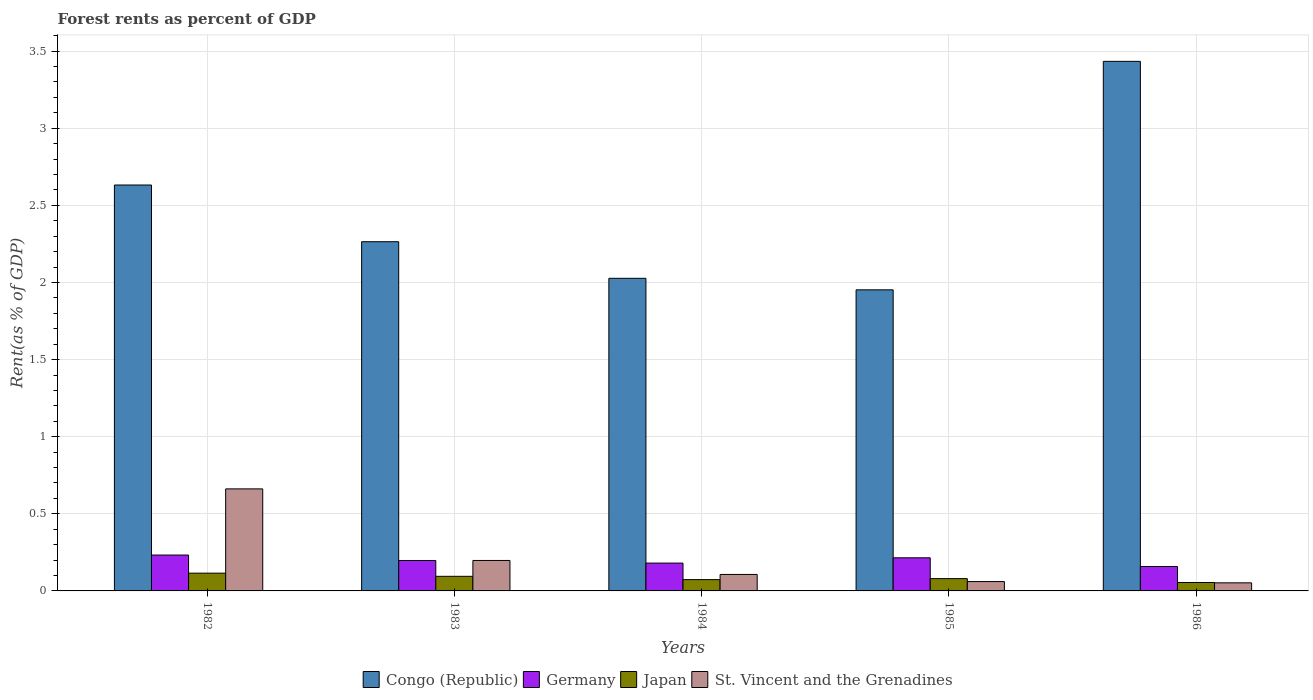How many groups of bars are there?
Provide a short and direct response. 5. Are the number of bars on each tick of the X-axis equal?
Give a very brief answer. Yes. What is the label of the 4th group of bars from the left?
Keep it short and to the point. 1985. What is the forest rent in Germany in 1983?
Give a very brief answer. 0.2. Across all years, what is the maximum forest rent in Japan?
Keep it short and to the point. 0.12. Across all years, what is the minimum forest rent in Japan?
Offer a very short reply. 0.05. In which year was the forest rent in St. Vincent and the Grenadines maximum?
Your response must be concise. 1982. What is the total forest rent in Japan in the graph?
Offer a terse response. 0.42. What is the difference between the forest rent in St. Vincent and the Grenadines in 1983 and that in 1986?
Make the answer very short. 0.15. What is the difference between the forest rent in Japan in 1982 and the forest rent in Germany in 1984?
Your response must be concise. -0.07. What is the average forest rent in Congo (Republic) per year?
Provide a succinct answer. 2.46. In the year 1982, what is the difference between the forest rent in Congo (Republic) and forest rent in Germany?
Ensure brevity in your answer.  2.4. What is the ratio of the forest rent in Japan in 1985 to that in 1986?
Provide a succinct answer. 1.46. Is the forest rent in Congo (Republic) in 1983 less than that in 1985?
Make the answer very short. No. Is the difference between the forest rent in Congo (Republic) in 1984 and 1986 greater than the difference between the forest rent in Germany in 1984 and 1986?
Make the answer very short. No. What is the difference between the highest and the second highest forest rent in St. Vincent and the Grenadines?
Your answer should be very brief. 0.46. What is the difference between the highest and the lowest forest rent in Japan?
Make the answer very short. 0.06. In how many years, is the forest rent in Germany greater than the average forest rent in Germany taken over all years?
Provide a succinct answer. 3. Is the sum of the forest rent in St. Vincent and the Grenadines in 1984 and 1985 greater than the maximum forest rent in Japan across all years?
Make the answer very short. Yes. Is it the case that in every year, the sum of the forest rent in Japan and forest rent in Congo (Republic) is greater than the sum of forest rent in Germany and forest rent in St. Vincent and the Grenadines?
Ensure brevity in your answer.  Yes. What does the 3rd bar from the right in 1985 represents?
Keep it short and to the point. Germany. Is it the case that in every year, the sum of the forest rent in Congo (Republic) and forest rent in St. Vincent and the Grenadines is greater than the forest rent in Germany?
Your response must be concise. Yes. How many bars are there?
Offer a terse response. 20. Are all the bars in the graph horizontal?
Offer a terse response. No. What is the difference between two consecutive major ticks on the Y-axis?
Provide a short and direct response. 0.5. Are the values on the major ticks of Y-axis written in scientific E-notation?
Provide a succinct answer. No. Does the graph contain any zero values?
Your answer should be compact. No. Where does the legend appear in the graph?
Ensure brevity in your answer.  Bottom center. How many legend labels are there?
Offer a very short reply. 4. How are the legend labels stacked?
Your answer should be compact. Horizontal. What is the title of the graph?
Your response must be concise. Forest rents as percent of GDP. Does "Tajikistan" appear as one of the legend labels in the graph?
Provide a succinct answer. No. What is the label or title of the X-axis?
Your answer should be very brief. Years. What is the label or title of the Y-axis?
Make the answer very short. Rent(as % of GDP). What is the Rent(as % of GDP) in Congo (Republic) in 1982?
Keep it short and to the point. 2.63. What is the Rent(as % of GDP) in Germany in 1982?
Ensure brevity in your answer.  0.23. What is the Rent(as % of GDP) of Japan in 1982?
Offer a terse response. 0.12. What is the Rent(as % of GDP) in St. Vincent and the Grenadines in 1982?
Ensure brevity in your answer.  0.66. What is the Rent(as % of GDP) of Congo (Republic) in 1983?
Give a very brief answer. 2.26. What is the Rent(as % of GDP) in Germany in 1983?
Provide a short and direct response. 0.2. What is the Rent(as % of GDP) in Japan in 1983?
Give a very brief answer. 0.09. What is the Rent(as % of GDP) of St. Vincent and the Grenadines in 1983?
Offer a terse response. 0.2. What is the Rent(as % of GDP) of Congo (Republic) in 1984?
Your answer should be compact. 2.03. What is the Rent(as % of GDP) of Germany in 1984?
Offer a terse response. 0.18. What is the Rent(as % of GDP) in Japan in 1984?
Give a very brief answer. 0.07. What is the Rent(as % of GDP) in St. Vincent and the Grenadines in 1984?
Make the answer very short. 0.11. What is the Rent(as % of GDP) in Congo (Republic) in 1985?
Your answer should be very brief. 1.95. What is the Rent(as % of GDP) of Germany in 1985?
Ensure brevity in your answer.  0.21. What is the Rent(as % of GDP) in Japan in 1985?
Give a very brief answer. 0.08. What is the Rent(as % of GDP) in St. Vincent and the Grenadines in 1985?
Give a very brief answer. 0.06. What is the Rent(as % of GDP) in Congo (Republic) in 1986?
Your answer should be compact. 3.43. What is the Rent(as % of GDP) in Germany in 1986?
Provide a short and direct response. 0.16. What is the Rent(as % of GDP) of Japan in 1986?
Provide a succinct answer. 0.05. What is the Rent(as % of GDP) in St. Vincent and the Grenadines in 1986?
Keep it short and to the point. 0.05. Across all years, what is the maximum Rent(as % of GDP) in Congo (Republic)?
Give a very brief answer. 3.43. Across all years, what is the maximum Rent(as % of GDP) of Germany?
Offer a terse response. 0.23. Across all years, what is the maximum Rent(as % of GDP) in Japan?
Offer a terse response. 0.12. Across all years, what is the maximum Rent(as % of GDP) of St. Vincent and the Grenadines?
Offer a very short reply. 0.66. Across all years, what is the minimum Rent(as % of GDP) in Congo (Republic)?
Your response must be concise. 1.95. Across all years, what is the minimum Rent(as % of GDP) in Germany?
Offer a terse response. 0.16. Across all years, what is the minimum Rent(as % of GDP) of Japan?
Offer a very short reply. 0.05. Across all years, what is the minimum Rent(as % of GDP) in St. Vincent and the Grenadines?
Keep it short and to the point. 0.05. What is the total Rent(as % of GDP) of Congo (Republic) in the graph?
Provide a short and direct response. 12.31. What is the total Rent(as % of GDP) of Germany in the graph?
Your answer should be compact. 0.98. What is the total Rent(as % of GDP) of Japan in the graph?
Ensure brevity in your answer.  0.42. What is the total Rent(as % of GDP) in St. Vincent and the Grenadines in the graph?
Your answer should be compact. 1.08. What is the difference between the Rent(as % of GDP) of Congo (Republic) in 1982 and that in 1983?
Make the answer very short. 0.37. What is the difference between the Rent(as % of GDP) in Germany in 1982 and that in 1983?
Provide a succinct answer. 0.04. What is the difference between the Rent(as % of GDP) in Japan in 1982 and that in 1983?
Your answer should be very brief. 0.02. What is the difference between the Rent(as % of GDP) in St. Vincent and the Grenadines in 1982 and that in 1983?
Offer a very short reply. 0.46. What is the difference between the Rent(as % of GDP) in Congo (Republic) in 1982 and that in 1984?
Your response must be concise. 0.6. What is the difference between the Rent(as % of GDP) in Germany in 1982 and that in 1984?
Provide a succinct answer. 0.05. What is the difference between the Rent(as % of GDP) of Japan in 1982 and that in 1984?
Offer a terse response. 0.04. What is the difference between the Rent(as % of GDP) in St. Vincent and the Grenadines in 1982 and that in 1984?
Your response must be concise. 0.55. What is the difference between the Rent(as % of GDP) of Congo (Republic) in 1982 and that in 1985?
Give a very brief answer. 0.68. What is the difference between the Rent(as % of GDP) in Germany in 1982 and that in 1985?
Give a very brief answer. 0.02. What is the difference between the Rent(as % of GDP) of Japan in 1982 and that in 1985?
Provide a succinct answer. 0.04. What is the difference between the Rent(as % of GDP) in St. Vincent and the Grenadines in 1982 and that in 1985?
Give a very brief answer. 0.6. What is the difference between the Rent(as % of GDP) of Congo (Republic) in 1982 and that in 1986?
Give a very brief answer. -0.8. What is the difference between the Rent(as % of GDP) of Germany in 1982 and that in 1986?
Offer a terse response. 0.07. What is the difference between the Rent(as % of GDP) of Japan in 1982 and that in 1986?
Your answer should be compact. 0.06. What is the difference between the Rent(as % of GDP) in St. Vincent and the Grenadines in 1982 and that in 1986?
Give a very brief answer. 0.61. What is the difference between the Rent(as % of GDP) in Congo (Republic) in 1983 and that in 1984?
Offer a terse response. 0.24. What is the difference between the Rent(as % of GDP) of Germany in 1983 and that in 1984?
Make the answer very short. 0.02. What is the difference between the Rent(as % of GDP) of Japan in 1983 and that in 1984?
Ensure brevity in your answer.  0.02. What is the difference between the Rent(as % of GDP) of St. Vincent and the Grenadines in 1983 and that in 1984?
Your answer should be compact. 0.09. What is the difference between the Rent(as % of GDP) in Congo (Republic) in 1983 and that in 1985?
Give a very brief answer. 0.31. What is the difference between the Rent(as % of GDP) of Germany in 1983 and that in 1985?
Make the answer very short. -0.02. What is the difference between the Rent(as % of GDP) in Japan in 1983 and that in 1985?
Make the answer very short. 0.01. What is the difference between the Rent(as % of GDP) in St. Vincent and the Grenadines in 1983 and that in 1985?
Ensure brevity in your answer.  0.14. What is the difference between the Rent(as % of GDP) of Congo (Republic) in 1983 and that in 1986?
Offer a very short reply. -1.17. What is the difference between the Rent(as % of GDP) in Germany in 1983 and that in 1986?
Provide a succinct answer. 0.04. What is the difference between the Rent(as % of GDP) of Japan in 1983 and that in 1986?
Offer a terse response. 0.04. What is the difference between the Rent(as % of GDP) of St. Vincent and the Grenadines in 1983 and that in 1986?
Your answer should be compact. 0.14. What is the difference between the Rent(as % of GDP) of Congo (Republic) in 1984 and that in 1985?
Offer a terse response. 0.07. What is the difference between the Rent(as % of GDP) in Germany in 1984 and that in 1985?
Ensure brevity in your answer.  -0.03. What is the difference between the Rent(as % of GDP) of Japan in 1984 and that in 1985?
Give a very brief answer. -0.01. What is the difference between the Rent(as % of GDP) of St. Vincent and the Grenadines in 1984 and that in 1985?
Keep it short and to the point. 0.05. What is the difference between the Rent(as % of GDP) in Congo (Republic) in 1984 and that in 1986?
Your answer should be very brief. -1.41. What is the difference between the Rent(as % of GDP) of Germany in 1984 and that in 1986?
Offer a terse response. 0.02. What is the difference between the Rent(as % of GDP) of Japan in 1984 and that in 1986?
Give a very brief answer. 0.02. What is the difference between the Rent(as % of GDP) in St. Vincent and the Grenadines in 1984 and that in 1986?
Your response must be concise. 0.05. What is the difference between the Rent(as % of GDP) of Congo (Republic) in 1985 and that in 1986?
Provide a succinct answer. -1.48. What is the difference between the Rent(as % of GDP) in Germany in 1985 and that in 1986?
Provide a short and direct response. 0.06. What is the difference between the Rent(as % of GDP) of Japan in 1985 and that in 1986?
Your answer should be very brief. 0.03. What is the difference between the Rent(as % of GDP) in St. Vincent and the Grenadines in 1985 and that in 1986?
Make the answer very short. 0.01. What is the difference between the Rent(as % of GDP) of Congo (Republic) in 1982 and the Rent(as % of GDP) of Germany in 1983?
Your answer should be compact. 2.43. What is the difference between the Rent(as % of GDP) of Congo (Republic) in 1982 and the Rent(as % of GDP) of Japan in 1983?
Offer a terse response. 2.54. What is the difference between the Rent(as % of GDP) in Congo (Republic) in 1982 and the Rent(as % of GDP) in St. Vincent and the Grenadines in 1983?
Your answer should be compact. 2.43. What is the difference between the Rent(as % of GDP) in Germany in 1982 and the Rent(as % of GDP) in Japan in 1983?
Your response must be concise. 0.14. What is the difference between the Rent(as % of GDP) of Germany in 1982 and the Rent(as % of GDP) of St. Vincent and the Grenadines in 1983?
Your response must be concise. 0.04. What is the difference between the Rent(as % of GDP) in Japan in 1982 and the Rent(as % of GDP) in St. Vincent and the Grenadines in 1983?
Provide a short and direct response. -0.08. What is the difference between the Rent(as % of GDP) in Congo (Republic) in 1982 and the Rent(as % of GDP) in Germany in 1984?
Your response must be concise. 2.45. What is the difference between the Rent(as % of GDP) in Congo (Republic) in 1982 and the Rent(as % of GDP) in Japan in 1984?
Provide a short and direct response. 2.56. What is the difference between the Rent(as % of GDP) in Congo (Republic) in 1982 and the Rent(as % of GDP) in St. Vincent and the Grenadines in 1984?
Your answer should be compact. 2.52. What is the difference between the Rent(as % of GDP) in Germany in 1982 and the Rent(as % of GDP) in Japan in 1984?
Offer a terse response. 0.16. What is the difference between the Rent(as % of GDP) of Germany in 1982 and the Rent(as % of GDP) of St. Vincent and the Grenadines in 1984?
Provide a succinct answer. 0.13. What is the difference between the Rent(as % of GDP) in Japan in 1982 and the Rent(as % of GDP) in St. Vincent and the Grenadines in 1984?
Give a very brief answer. 0.01. What is the difference between the Rent(as % of GDP) in Congo (Republic) in 1982 and the Rent(as % of GDP) in Germany in 1985?
Provide a short and direct response. 2.42. What is the difference between the Rent(as % of GDP) of Congo (Republic) in 1982 and the Rent(as % of GDP) of Japan in 1985?
Ensure brevity in your answer.  2.55. What is the difference between the Rent(as % of GDP) of Congo (Republic) in 1982 and the Rent(as % of GDP) of St. Vincent and the Grenadines in 1985?
Keep it short and to the point. 2.57. What is the difference between the Rent(as % of GDP) in Germany in 1982 and the Rent(as % of GDP) in Japan in 1985?
Your response must be concise. 0.15. What is the difference between the Rent(as % of GDP) in Germany in 1982 and the Rent(as % of GDP) in St. Vincent and the Grenadines in 1985?
Offer a very short reply. 0.17. What is the difference between the Rent(as % of GDP) of Japan in 1982 and the Rent(as % of GDP) of St. Vincent and the Grenadines in 1985?
Give a very brief answer. 0.05. What is the difference between the Rent(as % of GDP) in Congo (Republic) in 1982 and the Rent(as % of GDP) in Germany in 1986?
Give a very brief answer. 2.47. What is the difference between the Rent(as % of GDP) in Congo (Republic) in 1982 and the Rent(as % of GDP) in Japan in 1986?
Ensure brevity in your answer.  2.58. What is the difference between the Rent(as % of GDP) of Congo (Republic) in 1982 and the Rent(as % of GDP) of St. Vincent and the Grenadines in 1986?
Your answer should be compact. 2.58. What is the difference between the Rent(as % of GDP) in Germany in 1982 and the Rent(as % of GDP) in Japan in 1986?
Provide a succinct answer. 0.18. What is the difference between the Rent(as % of GDP) of Germany in 1982 and the Rent(as % of GDP) of St. Vincent and the Grenadines in 1986?
Give a very brief answer. 0.18. What is the difference between the Rent(as % of GDP) of Japan in 1982 and the Rent(as % of GDP) of St. Vincent and the Grenadines in 1986?
Provide a succinct answer. 0.06. What is the difference between the Rent(as % of GDP) in Congo (Republic) in 1983 and the Rent(as % of GDP) in Germany in 1984?
Ensure brevity in your answer.  2.08. What is the difference between the Rent(as % of GDP) of Congo (Republic) in 1983 and the Rent(as % of GDP) of Japan in 1984?
Your response must be concise. 2.19. What is the difference between the Rent(as % of GDP) of Congo (Republic) in 1983 and the Rent(as % of GDP) of St. Vincent and the Grenadines in 1984?
Your response must be concise. 2.16. What is the difference between the Rent(as % of GDP) in Germany in 1983 and the Rent(as % of GDP) in Japan in 1984?
Offer a very short reply. 0.12. What is the difference between the Rent(as % of GDP) of Germany in 1983 and the Rent(as % of GDP) of St. Vincent and the Grenadines in 1984?
Keep it short and to the point. 0.09. What is the difference between the Rent(as % of GDP) of Japan in 1983 and the Rent(as % of GDP) of St. Vincent and the Grenadines in 1984?
Offer a very short reply. -0.01. What is the difference between the Rent(as % of GDP) of Congo (Republic) in 1983 and the Rent(as % of GDP) of Germany in 1985?
Ensure brevity in your answer.  2.05. What is the difference between the Rent(as % of GDP) in Congo (Republic) in 1983 and the Rent(as % of GDP) in Japan in 1985?
Your answer should be compact. 2.18. What is the difference between the Rent(as % of GDP) in Congo (Republic) in 1983 and the Rent(as % of GDP) in St. Vincent and the Grenadines in 1985?
Keep it short and to the point. 2.2. What is the difference between the Rent(as % of GDP) in Germany in 1983 and the Rent(as % of GDP) in Japan in 1985?
Your response must be concise. 0.12. What is the difference between the Rent(as % of GDP) of Germany in 1983 and the Rent(as % of GDP) of St. Vincent and the Grenadines in 1985?
Keep it short and to the point. 0.14. What is the difference between the Rent(as % of GDP) in Japan in 1983 and the Rent(as % of GDP) in St. Vincent and the Grenadines in 1985?
Your response must be concise. 0.03. What is the difference between the Rent(as % of GDP) of Congo (Republic) in 1983 and the Rent(as % of GDP) of Germany in 1986?
Your answer should be compact. 2.11. What is the difference between the Rent(as % of GDP) of Congo (Republic) in 1983 and the Rent(as % of GDP) of Japan in 1986?
Offer a terse response. 2.21. What is the difference between the Rent(as % of GDP) in Congo (Republic) in 1983 and the Rent(as % of GDP) in St. Vincent and the Grenadines in 1986?
Ensure brevity in your answer.  2.21. What is the difference between the Rent(as % of GDP) of Germany in 1983 and the Rent(as % of GDP) of Japan in 1986?
Your answer should be very brief. 0.14. What is the difference between the Rent(as % of GDP) in Germany in 1983 and the Rent(as % of GDP) in St. Vincent and the Grenadines in 1986?
Make the answer very short. 0.14. What is the difference between the Rent(as % of GDP) in Japan in 1983 and the Rent(as % of GDP) in St. Vincent and the Grenadines in 1986?
Make the answer very short. 0.04. What is the difference between the Rent(as % of GDP) of Congo (Republic) in 1984 and the Rent(as % of GDP) of Germany in 1985?
Ensure brevity in your answer.  1.81. What is the difference between the Rent(as % of GDP) in Congo (Republic) in 1984 and the Rent(as % of GDP) in Japan in 1985?
Give a very brief answer. 1.95. What is the difference between the Rent(as % of GDP) of Congo (Republic) in 1984 and the Rent(as % of GDP) of St. Vincent and the Grenadines in 1985?
Your response must be concise. 1.97. What is the difference between the Rent(as % of GDP) in Germany in 1984 and the Rent(as % of GDP) in Japan in 1985?
Your answer should be compact. 0.1. What is the difference between the Rent(as % of GDP) of Germany in 1984 and the Rent(as % of GDP) of St. Vincent and the Grenadines in 1985?
Give a very brief answer. 0.12. What is the difference between the Rent(as % of GDP) in Japan in 1984 and the Rent(as % of GDP) in St. Vincent and the Grenadines in 1985?
Make the answer very short. 0.01. What is the difference between the Rent(as % of GDP) of Congo (Republic) in 1984 and the Rent(as % of GDP) of Germany in 1986?
Provide a short and direct response. 1.87. What is the difference between the Rent(as % of GDP) of Congo (Republic) in 1984 and the Rent(as % of GDP) of Japan in 1986?
Provide a succinct answer. 1.97. What is the difference between the Rent(as % of GDP) in Congo (Republic) in 1984 and the Rent(as % of GDP) in St. Vincent and the Grenadines in 1986?
Give a very brief answer. 1.97. What is the difference between the Rent(as % of GDP) of Germany in 1984 and the Rent(as % of GDP) of Japan in 1986?
Offer a terse response. 0.13. What is the difference between the Rent(as % of GDP) of Germany in 1984 and the Rent(as % of GDP) of St. Vincent and the Grenadines in 1986?
Give a very brief answer. 0.13. What is the difference between the Rent(as % of GDP) of Japan in 1984 and the Rent(as % of GDP) of St. Vincent and the Grenadines in 1986?
Keep it short and to the point. 0.02. What is the difference between the Rent(as % of GDP) of Congo (Republic) in 1985 and the Rent(as % of GDP) of Germany in 1986?
Your response must be concise. 1.79. What is the difference between the Rent(as % of GDP) of Congo (Republic) in 1985 and the Rent(as % of GDP) of Japan in 1986?
Provide a succinct answer. 1.9. What is the difference between the Rent(as % of GDP) in Congo (Republic) in 1985 and the Rent(as % of GDP) in St. Vincent and the Grenadines in 1986?
Ensure brevity in your answer.  1.9. What is the difference between the Rent(as % of GDP) of Germany in 1985 and the Rent(as % of GDP) of Japan in 1986?
Offer a very short reply. 0.16. What is the difference between the Rent(as % of GDP) of Germany in 1985 and the Rent(as % of GDP) of St. Vincent and the Grenadines in 1986?
Your answer should be compact. 0.16. What is the difference between the Rent(as % of GDP) of Japan in 1985 and the Rent(as % of GDP) of St. Vincent and the Grenadines in 1986?
Make the answer very short. 0.03. What is the average Rent(as % of GDP) in Congo (Republic) per year?
Provide a short and direct response. 2.46. What is the average Rent(as % of GDP) in Germany per year?
Ensure brevity in your answer.  0.2. What is the average Rent(as % of GDP) in Japan per year?
Your answer should be compact. 0.08. What is the average Rent(as % of GDP) in St. Vincent and the Grenadines per year?
Provide a short and direct response. 0.22. In the year 1982, what is the difference between the Rent(as % of GDP) of Congo (Republic) and Rent(as % of GDP) of Germany?
Provide a succinct answer. 2.4. In the year 1982, what is the difference between the Rent(as % of GDP) of Congo (Republic) and Rent(as % of GDP) of Japan?
Provide a short and direct response. 2.52. In the year 1982, what is the difference between the Rent(as % of GDP) of Congo (Republic) and Rent(as % of GDP) of St. Vincent and the Grenadines?
Offer a terse response. 1.97. In the year 1982, what is the difference between the Rent(as % of GDP) of Germany and Rent(as % of GDP) of Japan?
Provide a short and direct response. 0.12. In the year 1982, what is the difference between the Rent(as % of GDP) in Germany and Rent(as % of GDP) in St. Vincent and the Grenadines?
Your answer should be very brief. -0.43. In the year 1982, what is the difference between the Rent(as % of GDP) of Japan and Rent(as % of GDP) of St. Vincent and the Grenadines?
Keep it short and to the point. -0.55. In the year 1983, what is the difference between the Rent(as % of GDP) in Congo (Republic) and Rent(as % of GDP) in Germany?
Give a very brief answer. 2.07. In the year 1983, what is the difference between the Rent(as % of GDP) in Congo (Republic) and Rent(as % of GDP) in Japan?
Give a very brief answer. 2.17. In the year 1983, what is the difference between the Rent(as % of GDP) of Congo (Republic) and Rent(as % of GDP) of St. Vincent and the Grenadines?
Keep it short and to the point. 2.07. In the year 1983, what is the difference between the Rent(as % of GDP) of Germany and Rent(as % of GDP) of Japan?
Provide a succinct answer. 0.1. In the year 1983, what is the difference between the Rent(as % of GDP) of Germany and Rent(as % of GDP) of St. Vincent and the Grenadines?
Give a very brief answer. -0. In the year 1983, what is the difference between the Rent(as % of GDP) in Japan and Rent(as % of GDP) in St. Vincent and the Grenadines?
Make the answer very short. -0.1. In the year 1984, what is the difference between the Rent(as % of GDP) in Congo (Republic) and Rent(as % of GDP) in Germany?
Your answer should be very brief. 1.85. In the year 1984, what is the difference between the Rent(as % of GDP) of Congo (Republic) and Rent(as % of GDP) of Japan?
Keep it short and to the point. 1.95. In the year 1984, what is the difference between the Rent(as % of GDP) in Congo (Republic) and Rent(as % of GDP) in St. Vincent and the Grenadines?
Your response must be concise. 1.92. In the year 1984, what is the difference between the Rent(as % of GDP) of Germany and Rent(as % of GDP) of Japan?
Keep it short and to the point. 0.11. In the year 1984, what is the difference between the Rent(as % of GDP) of Germany and Rent(as % of GDP) of St. Vincent and the Grenadines?
Provide a short and direct response. 0.07. In the year 1984, what is the difference between the Rent(as % of GDP) of Japan and Rent(as % of GDP) of St. Vincent and the Grenadines?
Offer a very short reply. -0.03. In the year 1985, what is the difference between the Rent(as % of GDP) of Congo (Republic) and Rent(as % of GDP) of Germany?
Keep it short and to the point. 1.74. In the year 1985, what is the difference between the Rent(as % of GDP) in Congo (Republic) and Rent(as % of GDP) in Japan?
Provide a succinct answer. 1.87. In the year 1985, what is the difference between the Rent(as % of GDP) in Congo (Republic) and Rent(as % of GDP) in St. Vincent and the Grenadines?
Offer a very short reply. 1.89. In the year 1985, what is the difference between the Rent(as % of GDP) in Germany and Rent(as % of GDP) in Japan?
Make the answer very short. 0.14. In the year 1985, what is the difference between the Rent(as % of GDP) of Germany and Rent(as % of GDP) of St. Vincent and the Grenadines?
Keep it short and to the point. 0.15. In the year 1985, what is the difference between the Rent(as % of GDP) in Japan and Rent(as % of GDP) in St. Vincent and the Grenadines?
Give a very brief answer. 0.02. In the year 1986, what is the difference between the Rent(as % of GDP) of Congo (Republic) and Rent(as % of GDP) of Germany?
Offer a terse response. 3.28. In the year 1986, what is the difference between the Rent(as % of GDP) in Congo (Republic) and Rent(as % of GDP) in Japan?
Your answer should be very brief. 3.38. In the year 1986, what is the difference between the Rent(as % of GDP) in Congo (Republic) and Rent(as % of GDP) in St. Vincent and the Grenadines?
Give a very brief answer. 3.38. In the year 1986, what is the difference between the Rent(as % of GDP) of Germany and Rent(as % of GDP) of Japan?
Provide a short and direct response. 0.1. In the year 1986, what is the difference between the Rent(as % of GDP) in Germany and Rent(as % of GDP) in St. Vincent and the Grenadines?
Offer a very short reply. 0.11. In the year 1986, what is the difference between the Rent(as % of GDP) in Japan and Rent(as % of GDP) in St. Vincent and the Grenadines?
Offer a very short reply. 0. What is the ratio of the Rent(as % of GDP) in Congo (Republic) in 1982 to that in 1983?
Your answer should be very brief. 1.16. What is the ratio of the Rent(as % of GDP) of Germany in 1982 to that in 1983?
Offer a terse response. 1.18. What is the ratio of the Rent(as % of GDP) of Japan in 1982 to that in 1983?
Give a very brief answer. 1.22. What is the ratio of the Rent(as % of GDP) of St. Vincent and the Grenadines in 1982 to that in 1983?
Give a very brief answer. 3.35. What is the ratio of the Rent(as % of GDP) of Congo (Republic) in 1982 to that in 1984?
Ensure brevity in your answer.  1.3. What is the ratio of the Rent(as % of GDP) of Germany in 1982 to that in 1984?
Offer a very short reply. 1.29. What is the ratio of the Rent(as % of GDP) in Japan in 1982 to that in 1984?
Your answer should be compact. 1.57. What is the ratio of the Rent(as % of GDP) in St. Vincent and the Grenadines in 1982 to that in 1984?
Offer a very short reply. 6.19. What is the ratio of the Rent(as % of GDP) in Congo (Republic) in 1982 to that in 1985?
Provide a succinct answer. 1.35. What is the ratio of the Rent(as % of GDP) of Germany in 1982 to that in 1985?
Keep it short and to the point. 1.08. What is the ratio of the Rent(as % of GDP) of Japan in 1982 to that in 1985?
Your answer should be compact. 1.45. What is the ratio of the Rent(as % of GDP) of St. Vincent and the Grenadines in 1982 to that in 1985?
Your response must be concise. 10.92. What is the ratio of the Rent(as % of GDP) in Congo (Republic) in 1982 to that in 1986?
Make the answer very short. 0.77. What is the ratio of the Rent(as % of GDP) in Germany in 1982 to that in 1986?
Your answer should be compact. 1.47. What is the ratio of the Rent(as % of GDP) in Japan in 1982 to that in 1986?
Your response must be concise. 2.11. What is the ratio of the Rent(as % of GDP) in St. Vincent and the Grenadines in 1982 to that in 1986?
Ensure brevity in your answer.  12.62. What is the ratio of the Rent(as % of GDP) of Congo (Republic) in 1983 to that in 1984?
Your answer should be compact. 1.12. What is the ratio of the Rent(as % of GDP) of Germany in 1983 to that in 1984?
Provide a short and direct response. 1.09. What is the ratio of the Rent(as % of GDP) of Japan in 1983 to that in 1984?
Your response must be concise. 1.29. What is the ratio of the Rent(as % of GDP) in St. Vincent and the Grenadines in 1983 to that in 1984?
Your answer should be compact. 1.85. What is the ratio of the Rent(as % of GDP) of Congo (Republic) in 1983 to that in 1985?
Your answer should be very brief. 1.16. What is the ratio of the Rent(as % of GDP) of Germany in 1983 to that in 1985?
Provide a short and direct response. 0.92. What is the ratio of the Rent(as % of GDP) of Japan in 1983 to that in 1985?
Provide a succinct answer. 1.19. What is the ratio of the Rent(as % of GDP) in St. Vincent and the Grenadines in 1983 to that in 1985?
Your response must be concise. 3.26. What is the ratio of the Rent(as % of GDP) in Congo (Republic) in 1983 to that in 1986?
Provide a short and direct response. 0.66. What is the ratio of the Rent(as % of GDP) in Germany in 1983 to that in 1986?
Your answer should be compact. 1.25. What is the ratio of the Rent(as % of GDP) of Japan in 1983 to that in 1986?
Make the answer very short. 1.73. What is the ratio of the Rent(as % of GDP) of St. Vincent and the Grenadines in 1983 to that in 1986?
Offer a terse response. 3.77. What is the ratio of the Rent(as % of GDP) in Congo (Republic) in 1984 to that in 1985?
Provide a short and direct response. 1.04. What is the ratio of the Rent(as % of GDP) of Germany in 1984 to that in 1985?
Provide a short and direct response. 0.84. What is the ratio of the Rent(as % of GDP) in Japan in 1984 to that in 1985?
Offer a very short reply. 0.92. What is the ratio of the Rent(as % of GDP) of St. Vincent and the Grenadines in 1984 to that in 1985?
Provide a succinct answer. 1.76. What is the ratio of the Rent(as % of GDP) of Congo (Republic) in 1984 to that in 1986?
Provide a short and direct response. 0.59. What is the ratio of the Rent(as % of GDP) of Germany in 1984 to that in 1986?
Provide a short and direct response. 1.14. What is the ratio of the Rent(as % of GDP) in Japan in 1984 to that in 1986?
Provide a short and direct response. 1.34. What is the ratio of the Rent(as % of GDP) in St. Vincent and the Grenadines in 1984 to that in 1986?
Provide a short and direct response. 2.04. What is the ratio of the Rent(as % of GDP) of Congo (Republic) in 1985 to that in 1986?
Ensure brevity in your answer.  0.57. What is the ratio of the Rent(as % of GDP) of Germany in 1985 to that in 1986?
Your response must be concise. 1.36. What is the ratio of the Rent(as % of GDP) of Japan in 1985 to that in 1986?
Give a very brief answer. 1.46. What is the ratio of the Rent(as % of GDP) in St. Vincent and the Grenadines in 1985 to that in 1986?
Make the answer very short. 1.16. What is the difference between the highest and the second highest Rent(as % of GDP) of Congo (Republic)?
Provide a short and direct response. 0.8. What is the difference between the highest and the second highest Rent(as % of GDP) of Germany?
Keep it short and to the point. 0.02. What is the difference between the highest and the second highest Rent(as % of GDP) of Japan?
Provide a succinct answer. 0.02. What is the difference between the highest and the second highest Rent(as % of GDP) in St. Vincent and the Grenadines?
Your response must be concise. 0.46. What is the difference between the highest and the lowest Rent(as % of GDP) of Congo (Republic)?
Offer a terse response. 1.48. What is the difference between the highest and the lowest Rent(as % of GDP) of Germany?
Your answer should be very brief. 0.07. What is the difference between the highest and the lowest Rent(as % of GDP) in Japan?
Your answer should be compact. 0.06. What is the difference between the highest and the lowest Rent(as % of GDP) in St. Vincent and the Grenadines?
Offer a terse response. 0.61. 